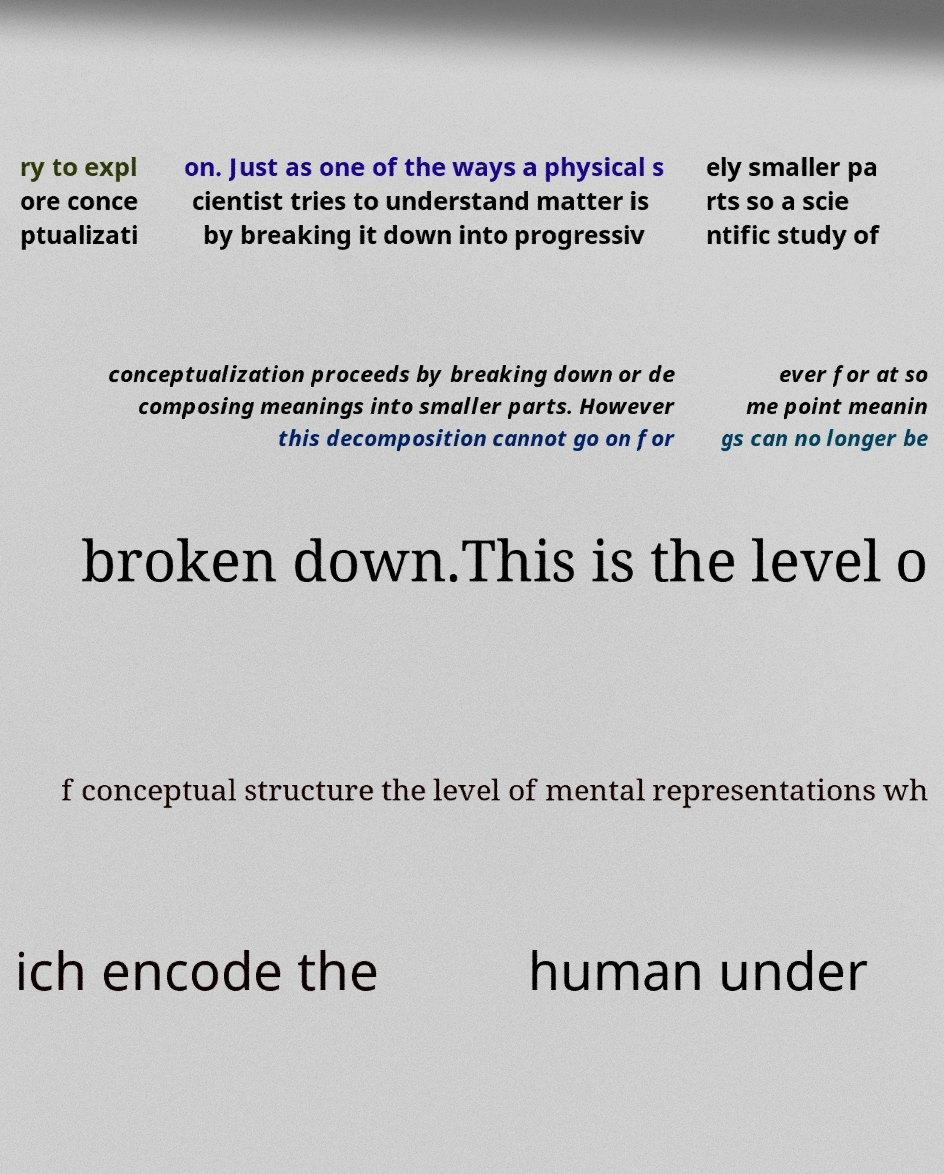I need the written content from this picture converted into text. Can you do that? ry to expl ore conce ptualizati on. Just as one of the ways a physical s cientist tries to understand matter is by breaking it down into progressiv ely smaller pa rts so a scie ntific study of conceptualization proceeds by breaking down or de composing meanings into smaller parts. However this decomposition cannot go on for ever for at so me point meanin gs can no longer be broken down.This is the level o f conceptual structure the level of mental representations wh ich encode the human under 